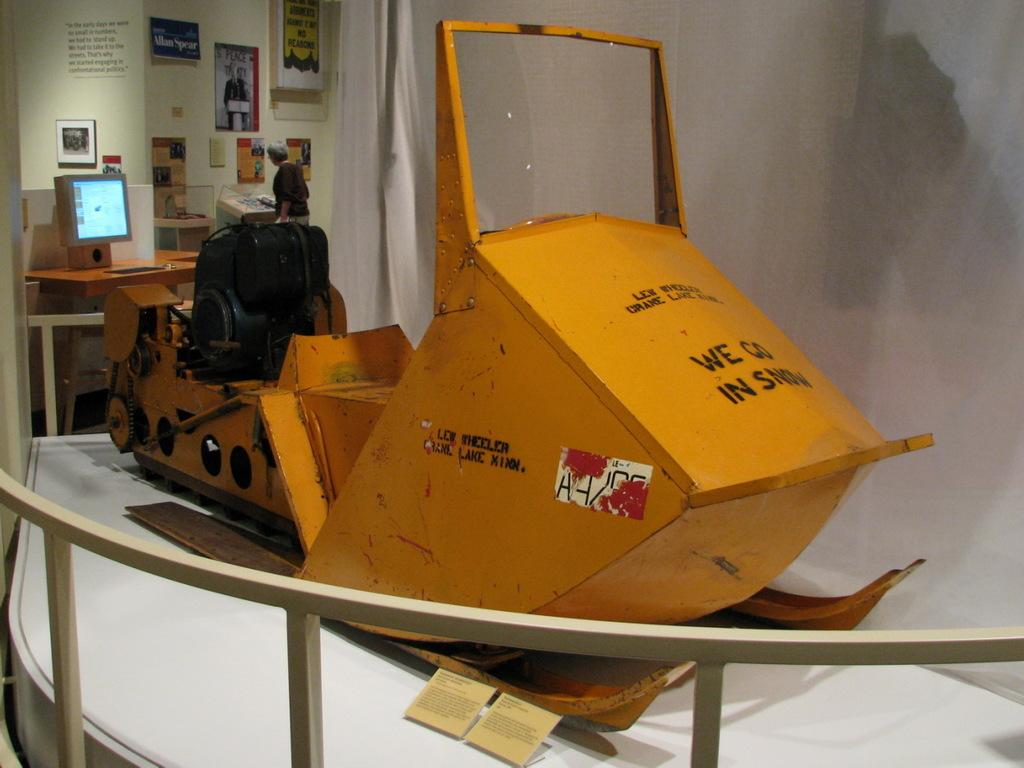What is placed on the table in the center of the image? There is an object placed on the table in the center of the image. What can be seen in the background of the image? There is a monitor, a person, a table, a wall, and photo frames in the background. What type of bone can be seen in the image? There is no bone present in the image. Can you see any mountains in the background of the image? There are no mountains visible in the image; only a monitor, a person, a table, a wall, and photo frames can be seen in the background. 